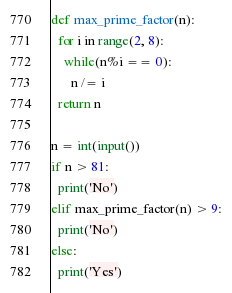<code> <loc_0><loc_0><loc_500><loc_500><_Python_>def max_prime_factor(n):
  for i in range(2, 8):
    while(n%i == 0):
      n /= i
  return n

n = int(input())
if n > 81:
  print('No')
elif max_prime_factor(n) > 9:
  print('No')
else:
  print('Yes')</code> 